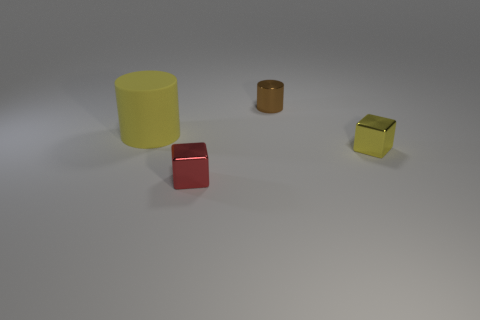What number of rubber objects are either big yellow cylinders or small yellow blocks?
Offer a very short reply. 1. There is a big yellow thing; what shape is it?
Ensure brevity in your answer.  Cylinder. There is a red object that is the same size as the yellow cube; what is it made of?
Make the answer very short. Metal. How many small objects are gray matte cubes or matte cylinders?
Make the answer very short. 0. Are any big yellow matte objects visible?
Provide a succinct answer. Yes. The red thing that is the same material as the small cylinder is what size?
Ensure brevity in your answer.  Small. Do the red block and the yellow block have the same material?
Ensure brevity in your answer.  Yes. How many other things are there of the same material as the big yellow cylinder?
Your response must be concise. 0. How many shiny cubes are both on the right side of the tiny cylinder and in front of the small yellow thing?
Your answer should be very brief. 0. What is the color of the large thing?
Your response must be concise. Yellow. 